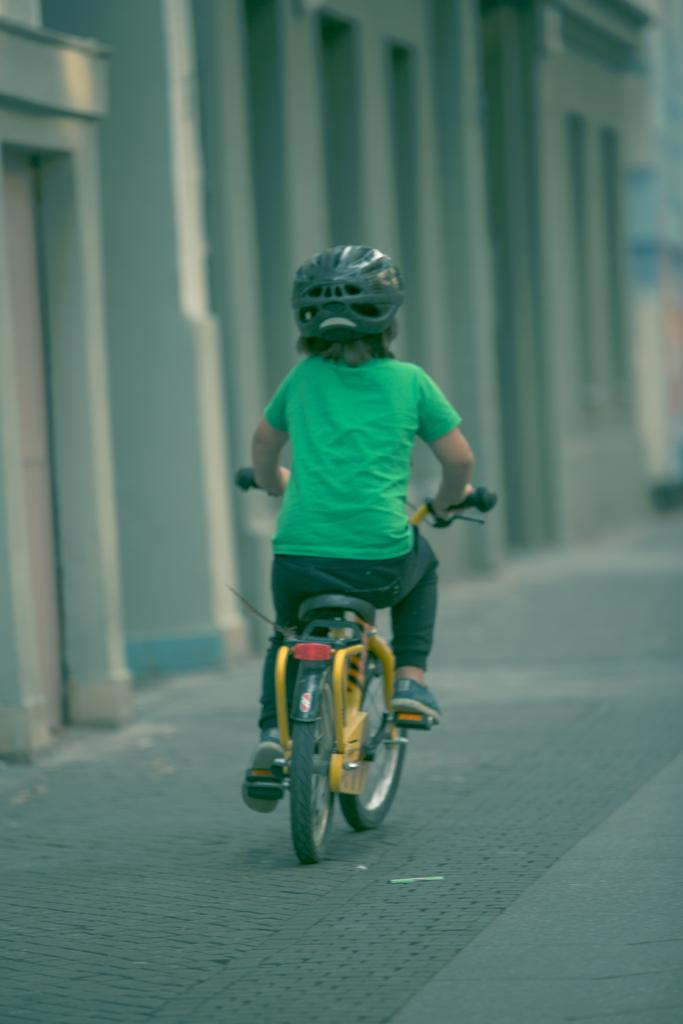What is the main subject of the image? The main subject of the image is a kid. What is the kid wearing in the image? The kid is wearing a helmet in the image. What activity is the kid engaged in? The kid is riding a bicycle in the image. What is located beside the kid? There is a wall beside the kid in the image. What time of day is it in the image, and is there a kitty playing nearby? The time of day is not mentioned in the image, and there is no kitty present in the image. 